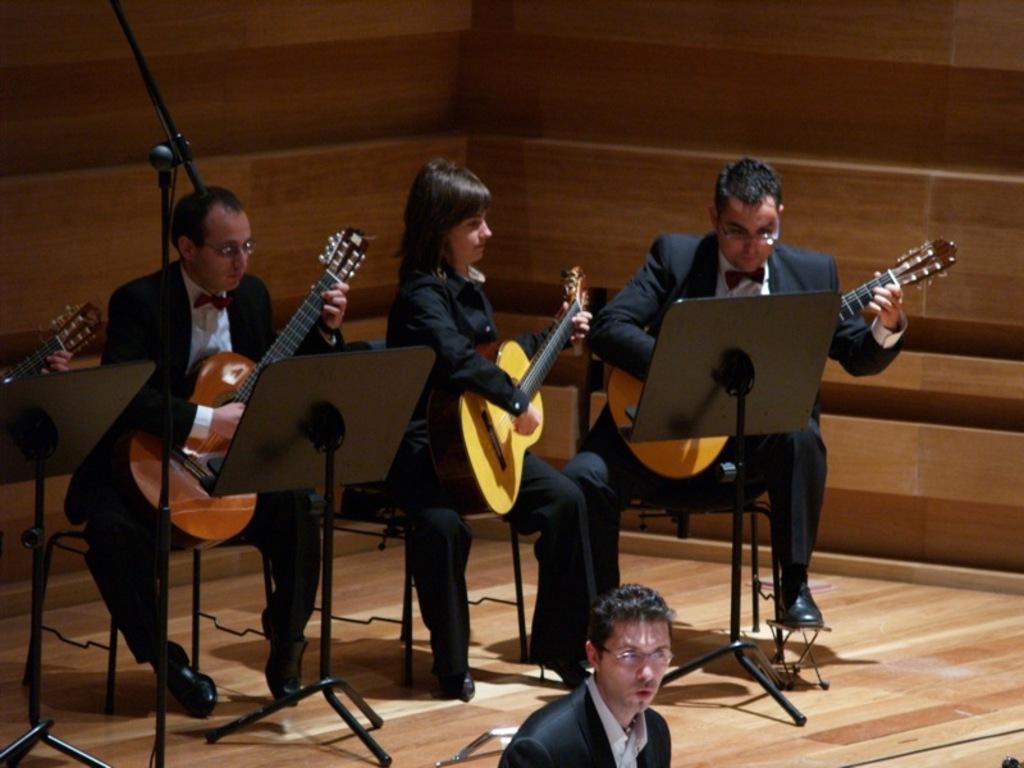Please provide a concise description of this image. This picture shows three people performing and playing a guitar. 